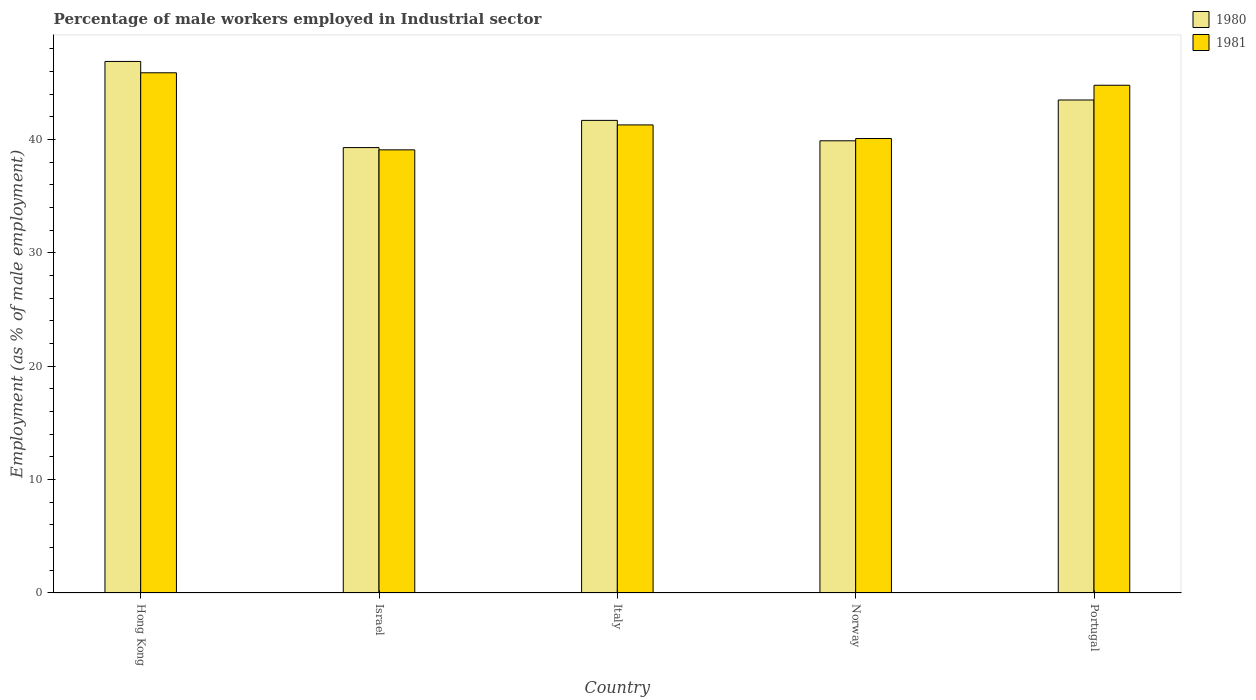How many different coloured bars are there?
Offer a very short reply. 2. In how many cases, is the number of bars for a given country not equal to the number of legend labels?
Make the answer very short. 0. What is the percentage of male workers employed in Industrial sector in 1980 in Portugal?
Provide a succinct answer. 43.5. Across all countries, what is the maximum percentage of male workers employed in Industrial sector in 1980?
Make the answer very short. 46.9. Across all countries, what is the minimum percentage of male workers employed in Industrial sector in 1981?
Give a very brief answer. 39.1. In which country was the percentage of male workers employed in Industrial sector in 1981 maximum?
Offer a terse response. Hong Kong. What is the total percentage of male workers employed in Industrial sector in 1980 in the graph?
Your response must be concise. 211.3. What is the difference between the percentage of male workers employed in Industrial sector in 1981 in Hong Kong and that in Israel?
Your response must be concise. 6.8. What is the difference between the percentage of male workers employed in Industrial sector in 1981 in Portugal and the percentage of male workers employed in Industrial sector in 1980 in Norway?
Give a very brief answer. 4.9. What is the average percentage of male workers employed in Industrial sector in 1981 per country?
Keep it short and to the point. 42.24. What is the difference between the percentage of male workers employed in Industrial sector of/in 1981 and percentage of male workers employed in Industrial sector of/in 1980 in Portugal?
Offer a terse response. 1.3. What is the ratio of the percentage of male workers employed in Industrial sector in 1980 in Hong Kong to that in Italy?
Make the answer very short. 1.12. Is the percentage of male workers employed in Industrial sector in 1981 in Hong Kong less than that in Norway?
Keep it short and to the point. No. What is the difference between the highest and the second highest percentage of male workers employed in Industrial sector in 1981?
Your answer should be very brief. -3.5. What is the difference between the highest and the lowest percentage of male workers employed in Industrial sector in 1980?
Your answer should be compact. 7.6. In how many countries, is the percentage of male workers employed in Industrial sector in 1980 greater than the average percentage of male workers employed in Industrial sector in 1980 taken over all countries?
Your answer should be compact. 2. What does the 1st bar from the left in Hong Kong represents?
Your response must be concise. 1980. What does the 2nd bar from the right in Norway represents?
Offer a very short reply. 1980. Are all the bars in the graph horizontal?
Provide a short and direct response. No. How many countries are there in the graph?
Your response must be concise. 5. Does the graph contain any zero values?
Provide a short and direct response. No. Does the graph contain grids?
Ensure brevity in your answer.  No. How are the legend labels stacked?
Keep it short and to the point. Vertical. What is the title of the graph?
Offer a terse response. Percentage of male workers employed in Industrial sector. What is the label or title of the Y-axis?
Provide a succinct answer. Employment (as % of male employment). What is the Employment (as % of male employment) of 1980 in Hong Kong?
Provide a succinct answer. 46.9. What is the Employment (as % of male employment) in 1981 in Hong Kong?
Offer a very short reply. 45.9. What is the Employment (as % of male employment) in 1980 in Israel?
Provide a short and direct response. 39.3. What is the Employment (as % of male employment) of 1981 in Israel?
Ensure brevity in your answer.  39.1. What is the Employment (as % of male employment) in 1980 in Italy?
Your response must be concise. 41.7. What is the Employment (as % of male employment) in 1981 in Italy?
Make the answer very short. 41.3. What is the Employment (as % of male employment) of 1980 in Norway?
Your response must be concise. 39.9. What is the Employment (as % of male employment) in 1981 in Norway?
Keep it short and to the point. 40.1. What is the Employment (as % of male employment) of 1980 in Portugal?
Ensure brevity in your answer.  43.5. What is the Employment (as % of male employment) in 1981 in Portugal?
Provide a short and direct response. 44.8. Across all countries, what is the maximum Employment (as % of male employment) of 1980?
Your response must be concise. 46.9. Across all countries, what is the maximum Employment (as % of male employment) of 1981?
Keep it short and to the point. 45.9. Across all countries, what is the minimum Employment (as % of male employment) of 1980?
Offer a very short reply. 39.3. Across all countries, what is the minimum Employment (as % of male employment) in 1981?
Offer a very short reply. 39.1. What is the total Employment (as % of male employment) in 1980 in the graph?
Your answer should be very brief. 211.3. What is the total Employment (as % of male employment) of 1981 in the graph?
Offer a very short reply. 211.2. What is the difference between the Employment (as % of male employment) in 1981 in Hong Kong and that in Norway?
Offer a very short reply. 5.8. What is the difference between the Employment (as % of male employment) in 1981 in Hong Kong and that in Portugal?
Keep it short and to the point. 1.1. What is the difference between the Employment (as % of male employment) of 1980 in Israel and that in Italy?
Make the answer very short. -2.4. What is the difference between the Employment (as % of male employment) of 1981 in Israel and that in Italy?
Provide a short and direct response. -2.2. What is the difference between the Employment (as % of male employment) of 1981 in Israel and that in Portugal?
Provide a short and direct response. -5.7. What is the difference between the Employment (as % of male employment) of 1980 in Italy and that in Norway?
Give a very brief answer. 1.8. What is the difference between the Employment (as % of male employment) of 1981 in Norway and that in Portugal?
Your answer should be very brief. -4.7. What is the difference between the Employment (as % of male employment) of 1980 in Hong Kong and the Employment (as % of male employment) of 1981 in Italy?
Ensure brevity in your answer.  5.6. What is the difference between the Employment (as % of male employment) of 1980 in Hong Kong and the Employment (as % of male employment) of 1981 in Norway?
Your answer should be compact. 6.8. What is the difference between the Employment (as % of male employment) in 1980 in Hong Kong and the Employment (as % of male employment) in 1981 in Portugal?
Give a very brief answer. 2.1. What is the difference between the Employment (as % of male employment) in 1980 in Israel and the Employment (as % of male employment) in 1981 in Italy?
Offer a very short reply. -2. What is the difference between the Employment (as % of male employment) of 1980 in Israel and the Employment (as % of male employment) of 1981 in Norway?
Your answer should be very brief. -0.8. What is the difference between the Employment (as % of male employment) in 1980 in Israel and the Employment (as % of male employment) in 1981 in Portugal?
Offer a very short reply. -5.5. What is the average Employment (as % of male employment) of 1980 per country?
Make the answer very short. 42.26. What is the average Employment (as % of male employment) of 1981 per country?
Your answer should be compact. 42.24. What is the difference between the Employment (as % of male employment) in 1980 and Employment (as % of male employment) in 1981 in Israel?
Your answer should be very brief. 0.2. What is the difference between the Employment (as % of male employment) in 1980 and Employment (as % of male employment) in 1981 in Italy?
Provide a short and direct response. 0.4. What is the difference between the Employment (as % of male employment) of 1980 and Employment (as % of male employment) of 1981 in Norway?
Provide a short and direct response. -0.2. What is the difference between the Employment (as % of male employment) in 1980 and Employment (as % of male employment) in 1981 in Portugal?
Give a very brief answer. -1.3. What is the ratio of the Employment (as % of male employment) in 1980 in Hong Kong to that in Israel?
Provide a short and direct response. 1.19. What is the ratio of the Employment (as % of male employment) in 1981 in Hong Kong to that in Israel?
Provide a succinct answer. 1.17. What is the ratio of the Employment (as % of male employment) of 1980 in Hong Kong to that in Italy?
Offer a very short reply. 1.12. What is the ratio of the Employment (as % of male employment) of 1981 in Hong Kong to that in Italy?
Make the answer very short. 1.11. What is the ratio of the Employment (as % of male employment) of 1980 in Hong Kong to that in Norway?
Ensure brevity in your answer.  1.18. What is the ratio of the Employment (as % of male employment) in 1981 in Hong Kong to that in Norway?
Keep it short and to the point. 1.14. What is the ratio of the Employment (as % of male employment) of 1980 in Hong Kong to that in Portugal?
Your response must be concise. 1.08. What is the ratio of the Employment (as % of male employment) in 1981 in Hong Kong to that in Portugal?
Provide a short and direct response. 1.02. What is the ratio of the Employment (as % of male employment) in 1980 in Israel to that in Italy?
Your answer should be very brief. 0.94. What is the ratio of the Employment (as % of male employment) of 1981 in Israel to that in Italy?
Your answer should be very brief. 0.95. What is the ratio of the Employment (as % of male employment) in 1981 in Israel to that in Norway?
Provide a succinct answer. 0.98. What is the ratio of the Employment (as % of male employment) in 1980 in Israel to that in Portugal?
Give a very brief answer. 0.9. What is the ratio of the Employment (as % of male employment) in 1981 in Israel to that in Portugal?
Provide a short and direct response. 0.87. What is the ratio of the Employment (as % of male employment) in 1980 in Italy to that in Norway?
Your answer should be compact. 1.05. What is the ratio of the Employment (as % of male employment) in 1981 in Italy to that in Norway?
Your answer should be very brief. 1.03. What is the ratio of the Employment (as % of male employment) of 1980 in Italy to that in Portugal?
Provide a succinct answer. 0.96. What is the ratio of the Employment (as % of male employment) of 1981 in Italy to that in Portugal?
Your response must be concise. 0.92. What is the ratio of the Employment (as % of male employment) in 1980 in Norway to that in Portugal?
Provide a succinct answer. 0.92. What is the ratio of the Employment (as % of male employment) in 1981 in Norway to that in Portugal?
Offer a very short reply. 0.9. What is the difference between the highest and the second highest Employment (as % of male employment) in 1980?
Keep it short and to the point. 3.4. What is the difference between the highest and the lowest Employment (as % of male employment) of 1980?
Your answer should be compact. 7.6. 